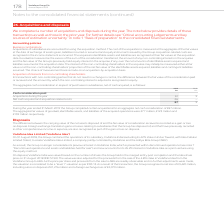From Vodafone Group Plc's financial document, What does cash consideration paid comprise of? The document shows two values: Acquisitions during the year and Net cash acquired and acquisition related costs. From the document: "sideration paid Acquisitions during the year 61 9 Net cash acquired and acquisition related costs 26 – 87 9 2019 2018 €m €m Cash consideration paid Ac..." Also, Which financial years' information is shown in the table? The document shows two values: 2018 and 2019. From the document: "2019 2018 €m €m Cash consideration paid Acquisitions during the year 61 9 Net cash acquired and acquisit 2019 2018 €m €m Cash consideration paid Acqui..." Also, How much is the 2019 acquisitions during the year ? According to the financial document, 61 (in millions). The relevant text states: "h consideration paid Acquisitions during the year 61 9 Net cash acquired and acquisition related costs 26 – 87 9..." Additionally, Between 2018 and 2019, which year had a greater amount of acquisitions during the year? According to the financial document, 2019. The relevant text states: "2019 2018 €m €m Cash consideration paid Acquisitions during the year 61 9 Net cash acquired and acquisit..." Additionally, Between 2018 and 2019, which year had a greater amount of cash consideration paid? According to the financial document, 2019. The relevant text states: "2019 2018 €m €m Cash consideration paid Acquisitions during the year 61 9 Net cash acquired and acquisit..." Also, can you calculate: What percentage of 2019 average cash consideration paid is the 2019 average acquisitions during the year? To answer this question, I need to perform calculations using the financial data. The calculation is: [(61+9)/2] / [(87+9)/2], which equals 72.92 (percentage). This is based on the information: "2019 2018 €m €m Cash consideration paid Acquisitions during the year 61 9 Net cash acquired and acqui 2019 2018 €m €m Cash consideration paid Acquisitions during the year 61 9 Net cash acquired and ac..." The key data points involved are: 61, 87. 